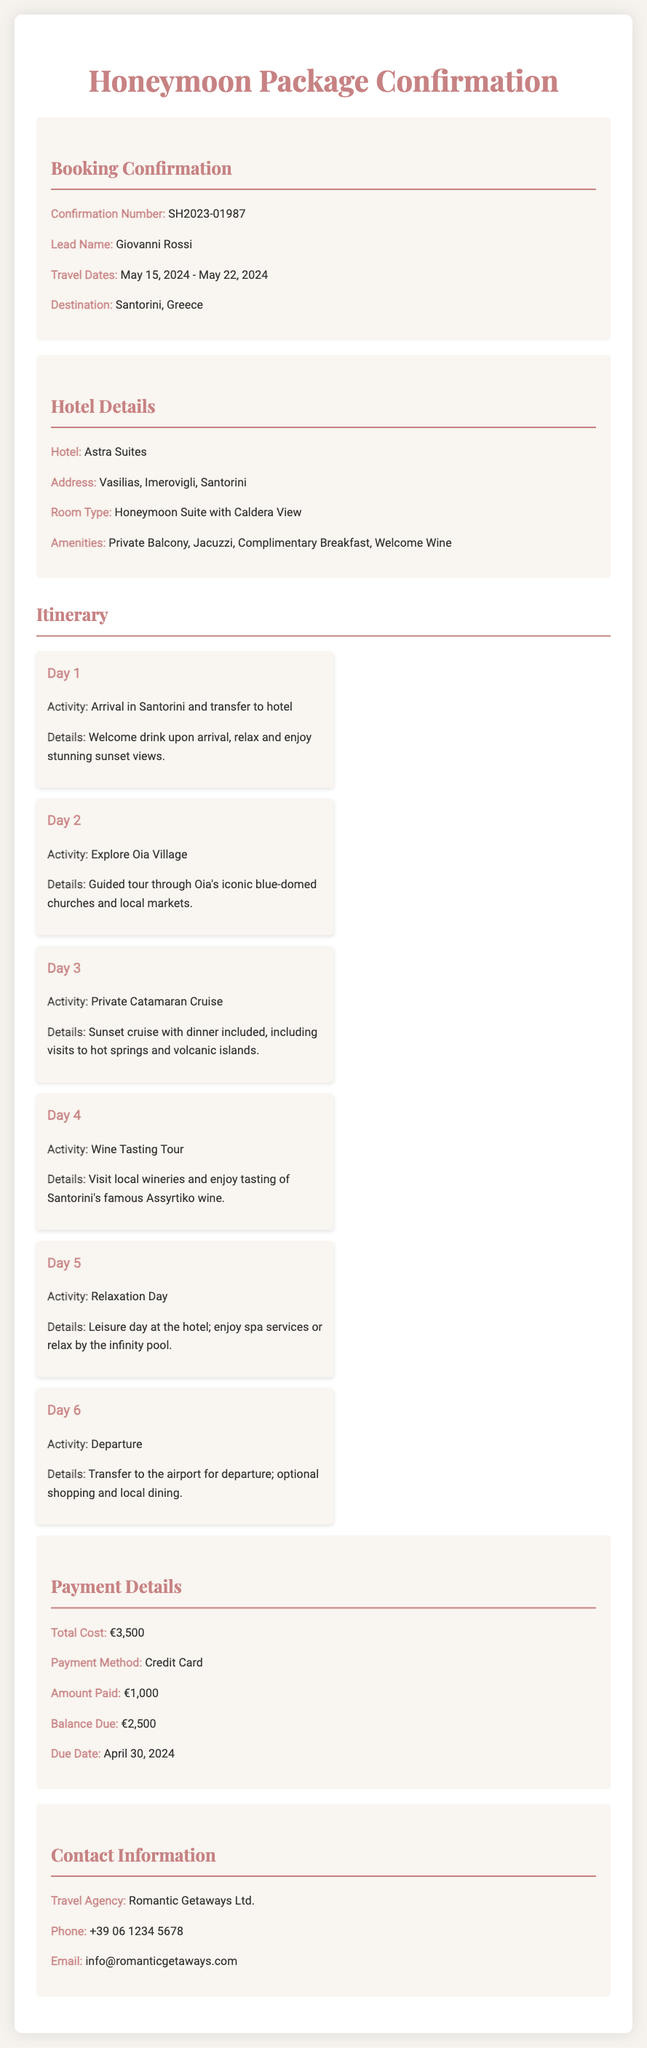What is the confirmation number? The confirmation number is listed in the booking confirmation section to identify the reservation.
Answer: SH2023-01987 What are the travel dates? The travel dates indicate the specified period for the honeymoon getaway and are essential for the booking.
Answer: May 15, 2024 - May 22, 2024 What hotel will the couple stay at? The hotel name is crucial for accommodation details during their honeymoon getaway.
Answer: Astra Suites How much is the total cost of the honeymoon package? The total cost summarizes the payment amount for the entire package, including all activities and hotel stays.
Answer: €3,500 What type of room is booked? The room type is important for understanding the couple's accommodation during their stay.
Answer: Honeymoon Suite with Caldera View How many days is the planned itinerary? The number of days in the itinerary provides insight into the duration of the honeymoon experience they can expect.
Answer: 6 days What activity is planned for Day 3? The activity planned for that day is vital for the couple's schedule and enjoyment during the honeymoon.
Answer: Private Catamaran Cruise When is the balance due date? The balance due date is critical for ensuring timely payment and avoiding cancellation of the booking.
Answer: April 30, 2024 What amenities are included in the hotel room? The included amenities enhance the couple's experience, making their stay more comfortable and special.
Answer: Private Balcony, Jacuzzi, Complimentary Breakfast, Welcome Wine 